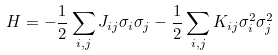Convert formula to latex. <formula><loc_0><loc_0><loc_500><loc_500>H = - \frac { 1 } { 2 } \sum _ { i , j } J _ { i j } \sigma _ { i } \sigma _ { j } - \frac { 1 } { 2 } \sum _ { i , j } K _ { i j } \sigma _ { i } ^ { 2 } \sigma _ { j } ^ { 2 }</formula> 